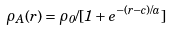<formula> <loc_0><loc_0><loc_500><loc_500>\rho _ { A } ( r ) = \rho _ { 0 } / [ 1 + e ^ { - ( r - c ) / a } ]</formula> 